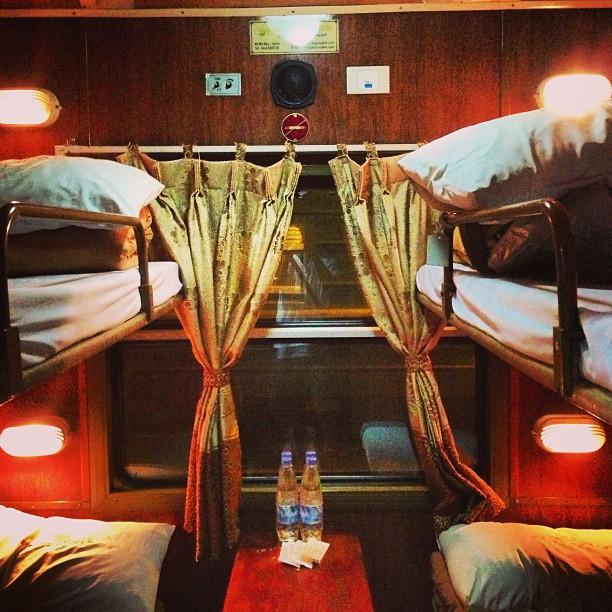How many bunks are there?
Concise answer only. 4. How many lights are in this room?
Short answer required. 5. What is on the table?
Concise answer only. Beer. 